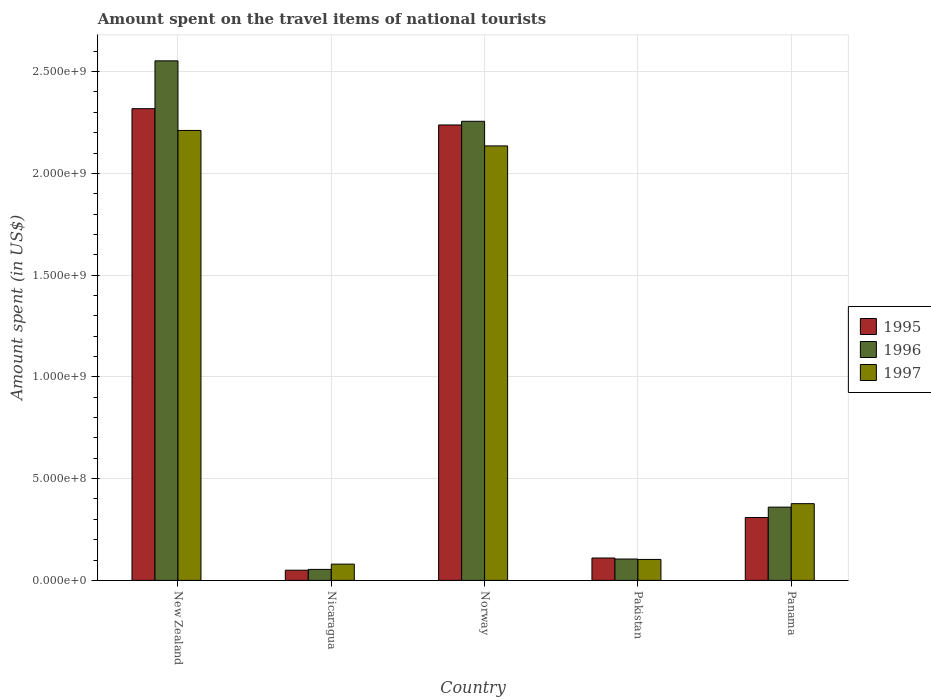Are the number of bars per tick equal to the number of legend labels?
Your answer should be very brief. Yes. Are the number of bars on each tick of the X-axis equal?
Ensure brevity in your answer.  Yes. What is the label of the 2nd group of bars from the left?
Your response must be concise. Nicaragua. What is the amount spent on the travel items of national tourists in 1996 in Panama?
Offer a very short reply. 3.60e+08. Across all countries, what is the maximum amount spent on the travel items of national tourists in 1996?
Your response must be concise. 2.55e+09. Across all countries, what is the minimum amount spent on the travel items of national tourists in 1997?
Your answer should be very brief. 8.00e+07. In which country was the amount spent on the travel items of national tourists in 1995 maximum?
Ensure brevity in your answer.  New Zealand. In which country was the amount spent on the travel items of national tourists in 1995 minimum?
Provide a short and direct response. Nicaragua. What is the total amount spent on the travel items of national tourists in 1995 in the graph?
Offer a very short reply. 5.02e+09. What is the difference between the amount spent on the travel items of national tourists in 1995 in Norway and that in Pakistan?
Your answer should be compact. 2.13e+09. What is the difference between the amount spent on the travel items of national tourists in 1997 in Nicaragua and the amount spent on the travel items of national tourists in 1995 in Norway?
Your response must be concise. -2.16e+09. What is the average amount spent on the travel items of national tourists in 1996 per country?
Keep it short and to the point. 1.07e+09. What is the difference between the amount spent on the travel items of national tourists of/in 1995 and amount spent on the travel items of national tourists of/in 1997 in Panama?
Offer a very short reply. -6.80e+07. What is the ratio of the amount spent on the travel items of national tourists in 1996 in Pakistan to that in Panama?
Your response must be concise. 0.29. What is the difference between the highest and the second highest amount spent on the travel items of national tourists in 1997?
Your response must be concise. 1.83e+09. What is the difference between the highest and the lowest amount spent on the travel items of national tourists in 1997?
Provide a short and direct response. 2.13e+09. In how many countries, is the amount spent on the travel items of national tourists in 1996 greater than the average amount spent on the travel items of national tourists in 1996 taken over all countries?
Keep it short and to the point. 2. What does the 1st bar from the left in Panama represents?
Ensure brevity in your answer.  1995. How many bars are there?
Keep it short and to the point. 15. Are the values on the major ticks of Y-axis written in scientific E-notation?
Keep it short and to the point. Yes. Does the graph contain grids?
Offer a terse response. Yes. How many legend labels are there?
Keep it short and to the point. 3. What is the title of the graph?
Ensure brevity in your answer.  Amount spent on the travel items of national tourists. Does "1972" appear as one of the legend labels in the graph?
Provide a succinct answer. No. What is the label or title of the X-axis?
Offer a terse response. Country. What is the label or title of the Y-axis?
Your answer should be very brief. Amount spent (in US$). What is the Amount spent (in US$) of 1995 in New Zealand?
Ensure brevity in your answer.  2.32e+09. What is the Amount spent (in US$) of 1996 in New Zealand?
Give a very brief answer. 2.55e+09. What is the Amount spent (in US$) of 1997 in New Zealand?
Provide a short and direct response. 2.21e+09. What is the Amount spent (in US$) in 1995 in Nicaragua?
Make the answer very short. 5.00e+07. What is the Amount spent (in US$) in 1996 in Nicaragua?
Make the answer very short. 5.40e+07. What is the Amount spent (in US$) of 1997 in Nicaragua?
Keep it short and to the point. 8.00e+07. What is the Amount spent (in US$) of 1995 in Norway?
Make the answer very short. 2.24e+09. What is the Amount spent (in US$) in 1996 in Norway?
Offer a terse response. 2.26e+09. What is the Amount spent (in US$) in 1997 in Norway?
Give a very brief answer. 2.14e+09. What is the Amount spent (in US$) in 1995 in Pakistan?
Offer a terse response. 1.10e+08. What is the Amount spent (in US$) in 1996 in Pakistan?
Your response must be concise. 1.05e+08. What is the Amount spent (in US$) in 1997 in Pakistan?
Keep it short and to the point. 1.03e+08. What is the Amount spent (in US$) in 1995 in Panama?
Give a very brief answer. 3.09e+08. What is the Amount spent (in US$) of 1996 in Panama?
Your answer should be very brief. 3.60e+08. What is the Amount spent (in US$) in 1997 in Panama?
Provide a short and direct response. 3.77e+08. Across all countries, what is the maximum Amount spent (in US$) in 1995?
Provide a succinct answer. 2.32e+09. Across all countries, what is the maximum Amount spent (in US$) in 1996?
Your response must be concise. 2.55e+09. Across all countries, what is the maximum Amount spent (in US$) of 1997?
Your answer should be compact. 2.21e+09. Across all countries, what is the minimum Amount spent (in US$) in 1995?
Your answer should be very brief. 5.00e+07. Across all countries, what is the minimum Amount spent (in US$) of 1996?
Your answer should be compact. 5.40e+07. Across all countries, what is the minimum Amount spent (in US$) in 1997?
Provide a succinct answer. 8.00e+07. What is the total Amount spent (in US$) of 1995 in the graph?
Ensure brevity in your answer.  5.02e+09. What is the total Amount spent (in US$) of 1996 in the graph?
Provide a succinct answer. 5.33e+09. What is the total Amount spent (in US$) in 1997 in the graph?
Ensure brevity in your answer.  4.91e+09. What is the difference between the Amount spent (in US$) of 1995 in New Zealand and that in Nicaragua?
Offer a very short reply. 2.27e+09. What is the difference between the Amount spent (in US$) in 1996 in New Zealand and that in Nicaragua?
Your answer should be compact. 2.50e+09. What is the difference between the Amount spent (in US$) of 1997 in New Zealand and that in Nicaragua?
Give a very brief answer. 2.13e+09. What is the difference between the Amount spent (in US$) of 1995 in New Zealand and that in Norway?
Offer a very short reply. 8.00e+07. What is the difference between the Amount spent (in US$) in 1996 in New Zealand and that in Norway?
Your response must be concise. 2.97e+08. What is the difference between the Amount spent (in US$) in 1997 in New Zealand and that in Norway?
Your answer should be very brief. 7.60e+07. What is the difference between the Amount spent (in US$) in 1995 in New Zealand and that in Pakistan?
Make the answer very short. 2.21e+09. What is the difference between the Amount spent (in US$) of 1996 in New Zealand and that in Pakistan?
Offer a terse response. 2.45e+09. What is the difference between the Amount spent (in US$) of 1997 in New Zealand and that in Pakistan?
Keep it short and to the point. 2.11e+09. What is the difference between the Amount spent (in US$) in 1995 in New Zealand and that in Panama?
Make the answer very short. 2.01e+09. What is the difference between the Amount spent (in US$) in 1996 in New Zealand and that in Panama?
Provide a succinct answer. 2.19e+09. What is the difference between the Amount spent (in US$) of 1997 in New Zealand and that in Panama?
Give a very brief answer. 1.83e+09. What is the difference between the Amount spent (in US$) in 1995 in Nicaragua and that in Norway?
Provide a succinct answer. -2.19e+09. What is the difference between the Amount spent (in US$) in 1996 in Nicaragua and that in Norway?
Your answer should be very brief. -2.20e+09. What is the difference between the Amount spent (in US$) in 1997 in Nicaragua and that in Norway?
Provide a short and direct response. -2.06e+09. What is the difference between the Amount spent (in US$) in 1995 in Nicaragua and that in Pakistan?
Make the answer very short. -6.00e+07. What is the difference between the Amount spent (in US$) in 1996 in Nicaragua and that in Pakistan?
Keep it short and to the point. -5.10e+07. What is the difference between the Amount spent (in US$) in 1997 in Nicaragua and that in Pakistan?
Offer a very short reply. -2.30e+07. What is the difference between the Amount spent (in US$) of 1995 in Nicaragua and that in Panama?
Your response must be concise. -2.59e+08. What is the difference between the Amount spent (in US$) in 1996 in Nicaragua and that in Panama?
Ensure brevity in your answer.  -3.06e+08. What is the difference between the Amount spent (in US$) of 1997 in Nicaragua and that in Panama?
Give a very brief answer. -2.97e+08. What is the difference between the Amount spent (in US$) in 1995 in Norway and that in Pakistan?
Offer a terse response. 2.13e+09. What is the difference between the Amount spent (in US$) in 1996 in Norway and that in Pakistan?
Keep it short and to the point. 2.15e+09. What is the difference between the Amount spent (in US$) in 1997 in Norway and that in Pakistan?
Ensure brevity in your answer.  2.03e+09. What is the difference between the Amount spent (in US$) in 1995 in Norway and that in Panama?
Make the answer very short. 1.93e+09. What is the difference between the Amount spent (in US$) in 1996 in Norway and that in Panama?
Your answer should be very brief. 1.90e+09. What is the difference between the Amount spent (in US$) in 1997 in Norway and that in Panama?
Your answer should be very brief. 1.76e+09. What is the difference between the Amount spent (in US$) of 1995 in Pakistan and that in Panama?
Ensure brevity in your answer.  -1.99e+08. What is the difference between the Amount spent (in US$) of 1996 in Pakistan and that in Panama?
Provide a short and direct response. -2.55e+08. What is the difference between the Amount spent (in US$) in 1997 in Pakistan and that in Panama?
Offer a terse response. -2.74e+08. What is the difference between the Amount spent (in US$) in 1995 in New Zealand and the Amount spent (in US$) in 1996 in Nicaragua?
Make the answer very short. 2.26e+09. What is the difference between the Amount spent (in US$) in 1995 in New Zealand and the Amount spent (in US$) in 1997 in Nicaragua?
Ensure brevity in your answer.  2.24e+09. What is the difference between the Amount spent (in US$) of 1996 in New Zealand and the Amount spent (in US$) of 1997 in Nicaragua?
Make the answer very short. 2.47e+09. What is the difference between the Amount spent (in US$) in 1995 in New Zealand and the Amount spent (in US$) in 1996 in Norway?
Keep it short and to the point. 6.20e+07. What is the difference between the Amount spent (in US$) in 1995 in New Zealand and the Amount spent (in US$) in 1997 in Norway?
Your answer should be compact. 1.83e+08. What is the difference between the Amount spent (in US$) of 1996 in New Zealand and the Amount spent (in US$) of 1997 in Norway?
Offer a terse response. 4.18e+08. What is the difference between the Amount spent (in US$) of 1995 in New Zealand and the Amount spent (in US$) of 1996 in Pakistan?
Give a very brief answer. 2.21e+09. What is the difference between the Amount spent (in US$) of 1995 in New Zealand and the Amount spent (in US$) of 1997 in Pakistan?
Your answer should be very brief. 2.22e+09. What is the difference between the Amount spent (in US$) in 1996 in New Zealand and the Amount spent (in US$) in 1997 in Pakistan?
Ensure brevity in your answer.  2.45e+09. What is the difference between the Amount spent (in US$) of 1995 in New Zealand and the Amount spent (in US$) of 1996 in Panama?
Your answer should be compact. 1.96e+09. What is the difference between the Amount spent (in US$) of 1995 in New Zealand and the Amount spent (in US$) of 1997 in Panama?
Offer a very short reply. 1.94e+09. What is the difference between the Amount spent (in US$) of 1996 in New Zealand and the Amount spent (in US$) of 1997 in Panama?
Give a very brief answer. 2.18e+09. What is the difference between the Amount spent (in US$) of 1995 in Nicaragua and the Amount spent (in US$) of 1996 in Norway?
Provide a short and direct response. -2.21e+09. What is the difference between the Amount spent (in US$) in 1995 in Nicaragua and the Amount spent (in US$) in 1997 in Norway?
Give a very brief answer. -2.08e+09. What is the difference between the Amount spent (in US$) of 1996 in Nicaragua and the Amount spent (in US$) of 1997 in Norway?
Keep it short and to the point. -2.08e+09. What is the difference between the Amount spent (in US$) in 1995 in Nicaragua and the Amount spent (in US$) in 1996 in Pakistan?
Your answer should be very brief. -5.50e+07. What is the difference between the Amount spent (in US$) of 1995 in Nicaragua and the Amount spent (in US$) of 1997 in Pakistan?
Offer a very short reply. -5.30e+07. What is the difference between the Amount spent (in US$) of 1996 in Nicaragua and the Amount spent (in US$) of 1997 in Pakistan?
Keep it short and to the point. -4.90e+07. What is the difference between the Amount spent (in US$) in 1995 in Nicaragua and the Amount spent (in US$) in 1996 in Panama?
Keep it short and to the point. -3.10e+08. What is the difference between the Amount spent (in US$) of 1995 in Nicaragua and the Amount spent (in US$) of 1997 in Panama?
Ensure brevity in your answer.  -3.27e+08. What is the difference between the Amount spent (in US$) of 1996 in Nicaragua and the Amount spent (in US$) of 1997 in Panama?
Your response must be concise. -3.23e+08. What is the difference between the Amount spent (in US$) in 1995 in Norway and the Amount spent (in US$) in 1996 in Pakistan?
Your response must be concise. 2.13e+09. What is the difference between the Amount spent (in US$) in 1995 in Norway and the Amount spent (in US$) in 1997 in Pakistan?
Your response must be concise. 2.14e+09. What is the difference between the Amount spent (in US$) in 1996 in Norway and the Amount spent (in US$) in 1997 in Pakistan?
Offer a very short reply. 2.15e+09. What is the difference between the Amount spent (in US$) in 1995 in Norway and the Amount spent (in US$) in 1996 in Panama?
Offer a very short reply. 1.88e+09. What is the difference between the Amount spent (in US$) in 1995 in Norway and the Amount spent (in US$) in 1997 in Panama?
Make the answer very short. 1.86e+09. What is the difference between the Amount spent (in US$) of 1996 in Norway and the Amount spent (in US$) of 1997 in Panama?
Your answer should be very brief. 1.88e+09. What is the difference between the Amount spent (in US$) in 1995 in Pakistan and the Amount spent (in US$) in 1996 in Panama?
Provide a succinct answer. -2.50e+08. What is the difference between the Amount spent (in US$) in 1995 in Pakistan and the Amount spent (in US$) in 1997 in Panama?
Keep it short and to the point. -2.67e+08. What is the difference between the Amount spent (in US$) in 1996 in Pakistan and the Amount spent (in US$) in 1997 in Panama?
Provide a succinct answer. -2.72e+08. What is the average Amount spent (in US$) in 1995 per country?
Provide a short and direct response. 1.00e+09. What is the average Amount spent (in US$) of 1996 per country?
Provide a short and direct response. 1.07e+09. What is the average Amount spent (in US$) in 1997 per country?
Ensure brevity in your answer.  9.81e+08. What is the difference between the Amount spent (in US$) of 1995 and Amount spent (in US$) of 1996 in New Zealand?
Provide a succinct answer. -2.35e+08. What is the difference between the Amount spent (in US$) in 1995 and Amount spent (in US$) in 1997 in New Zealand?
Give a very brief answer. 1.07e+08. What is the difference between the Amount spent (in US$) of 1996 and Amount spent (in US$) of 1997 in New Zealand?
Provide a succinct answer. 3.42e+08. What is the difference between the Amount spent (in US$) in 1995 and Amount spent (in US$) in 1996 in Nicaragua?
Offer a terse response. -4.00e+06. What is the difference between the Amount spent (in US$) in 1995 and Amount spent (in US$) in 1997 in Nicaragua?
Ensure brevity in your answer.  -3.00e+07. What is the difference between the Amount spent (in US$) of 1996 and Amount spent (in US$) of 1997 in Nicaragua?
Provide a succinct answer. -2.60e+07. What is the difference between the Amount spent (in US$) of 1995 and Amount spent (in US$) of 1996 in Norway?
Provide a short and direct response. -1.80e+07. What is the difference between the Amount spent (in US$) in 1995 and Amount spent (in US$) in 1997 in Norway?
Give a very brief answer. 1.03e+08. What is the difference between the Amount spent (in US$) in 1996 and Amount spent (in US$) in 1997 in Norway?
Provide a short and direct response. 1.21e+08. What is the difference between the Amount spent (in US$) of 1995 and Amount spent (in US$) of 1996 in Panama?
Provide a short and direct response. -5.10e+07. What is the difference between the Amount spent (in US$) in 1995 and Amount spent (in US$) in 1997 in Panama?
Ensure brevity in your answer.  -6.80e+07. What is the difference between the Amount spent (in US$) of 1996 and Amount spent (in US$) of 1997 in Panama?
Your answer should be very brief. -1.70e+07. What is the ratio of the Amount spent (in US$) in 1995 in New Zealand to that in Nicaragua?
Offer a terse response. 46.36. What is the ratio of the Amount spent (in US$) of 1996 in New Zealand to that in Nicaragua?
Offer a very short reply. 47.28. What is the ratio of the Amount spent (in US$) of 1997 in New Zealand to that in Nicaragua?
Make the answer very short. 27.64. What is the ratio of the Amount spent (in US$) of 1995 in New Zealand to that in Norway?
Give a very brief answer. 1.04. What is the ratio of the Amount spent (in US$) of 1996 in New Zealand to that in Norway?
Offer a very short reply. 1.13. What is the ratio of the Amount spent (in US$) of 1997 in New Zealand to that in Norway?
Provide a succinct answer. 1.04. What is the ratio of the Amount spent (in US$) of 1995 in New Zealand to that in Pakistan?
Make the answer very short. 21.07. What is the ratio of the Amount spent (in US$) of 1996 in New Zealand to that in Pakistan?
Provide a short and direct response. 24.31. What is the ratio of the Amount spent (in US$) in 1997 in New Zealand to that in Pakistan?
Give a very brief answer. 21.47. What is the ratio of the Amount spent (in US$) in 1995 in New Zealand to that in Panama?
Ensure brevity in your answer.  7.5. What is the ratio of the Amount spent (in US$) in 1996 in New Zealand to that in Panama?
Your response must be concise. 7.09. What is the ratio of the Amount spent (in US$) of 1997 in New Zealand to that in Panama?
Offer a terse response. 5.86. What is the ratio of the Amount spent (in US$) of 1995 in Nicaragua to that in Norway?
Make the answer very short. 0.02. What is the ratio of the Amount spent (in US$) of 1996 in Nicaragua to that in Norway?
Offer a very short reply. 0.02. What is the ratio of the Amount spent (in US$) in 1997 in Nicaragua to that in Norway?
Your answer should be very brief. 0.04. What is the ratio of the Amount spent (in US$) in 1995 in Nicaragua to that in Pakistan?
Provide a succinct answer. 0.45. What is the ratio of the Amount spent (in US$) of 1996 in Nicaragua to that in Pakistan?
Give a very brief answer. 0.51. What is the ratio of the Amount spent (in US$) in 1997 in Nicaragua to that in Pakistan?
Your answer should be very brief. 0.78. What is the ratio of the Amount spent (in US$) of 1995 in Nicaragua to that in Panama?
Offer a very short reply. 0.16. What is the ratio of the Amount spent (in US$) of 1996 in Nicaragua to that in Panama?
Provide a succinct answer. 0.15. What is the ratio of the Amount spent (in US$) in 1997 in Nicaragua to that in Panama?
Offer a very short reply. 0.21. What is the ratio of the Amount spent (in US$) of 1995 in Norway to that in Pakistan?
Your answer should be compact. 20.35. What is the ratio of the Amount spent (in US$) in 1996 in Norway to that in Pakistan?
Give a very brief answer. 21.49. What is the ratio of the Amount spent (in US$) in 1997 in Norway to that in Pakistan?
Your answer should be very brief. 20.73. What is the ratio of the Amount spent (in US$) in 1995 in Norway to that in Panama?
Offer a terse response. 7.24. What is the ratio of the Amount spent (in US$) in 1996 in Norway to that in Panama?
Give a very brief answer. 6.27. What is the ratio of the Amount spent (in US$) of 1997 in Norway to that in Panama?
Offer a terse response. 5.66. What is the ratio of the Amount spent (in US$) of 1995 in Pakistan to that in Panama?
Offer a terse response. 0.36. What is the ratio of the Amount spent (in US$) in 1996 in Pakistan to that in Panama?
Make the answer very short. 0.29. What is the ratio of the Amount spent (in US$) of 1997 in Pakistan to that in Panama?
Your response must be concise. 0.27. What is the difference between the highest and the second highest Amount spent (in US$) in 1995?
Give a very brief answer. 8.00e+07. What is the difference between the highest and the second highest Amount spent (in US$) of 1996?
Ensure brevity in your answer.  2.97e+08. What is the difference between the highest and the second highest Amount spent (in US$) of 1997?
Ensure brevity in your answer.  7.60e+07. What is the difference between the highest and the lowest Amount spent (in US$) in 1995?
Give a very brief answer. 2.27e+09. What is the difference between the highest and the lowest Amount spent (in US$) of 1996?
Make the answer very short. 2.50e+09. What is the difference between the highest and the lowest Amount spent (in US$) in 1997?
Provide a short and direct response. 2.13e+09. 